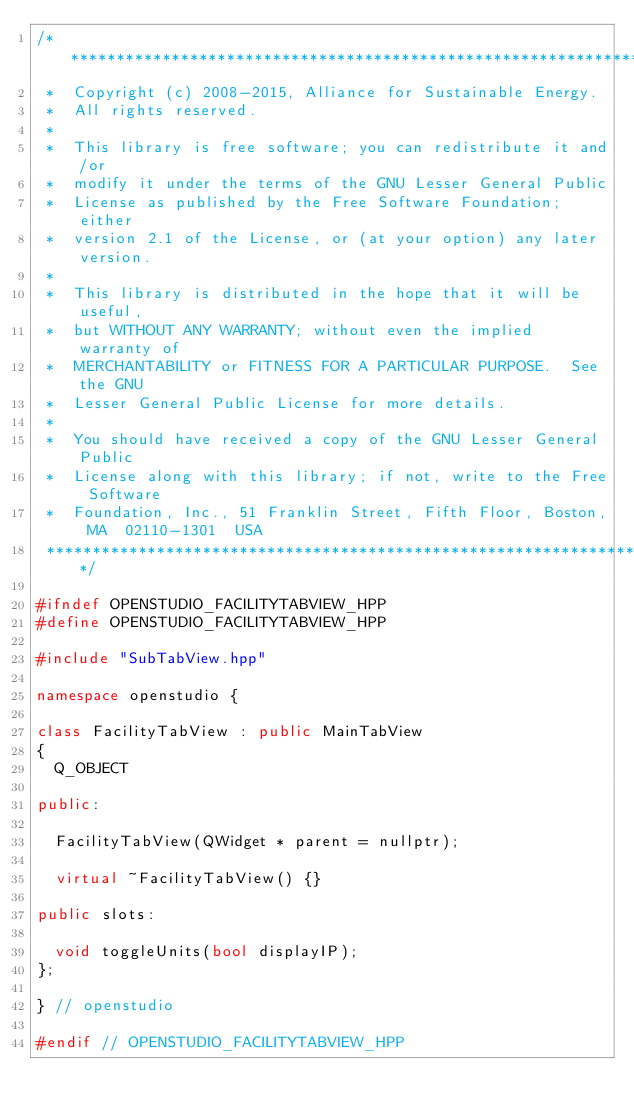Convert code to text. <code><loc_0><loc_0><loc_500><loc_500><_C++_>/**********************************************************************
 *  Copyright (c) 2008-2015, Alliance for Sustainable Energy.  
 *  All rights reserved.
 *  
 *  This library is free software; you can redistribute it and/or
 *  modify it under the terms of the GNU Lesser General Public
 *  License as published by the Free Software Foundation; either
 *  version 2.1 of the License, or (at your option) any later version.
 *  
 *  This library is distributed in the hope that it will be useful,
 *  but WITHOUT ANY WARRANTY; without even the implied warranty of
 *  MERCHANTABILITY or FITNESS FOR A PARTICULAR PURPOSE.  See the GNU
 *  Lesser General Public License for more details.
 *  
 *  You should have received a copy of the GNU Lesser General Public
 *  License along with this library; if not, write to the Free Software
 *  Foundation, Inc., 51 Franklin Street, Fifth Floor, Boston, MA  02110-1301  USA
 **********************************************************************/

#ifndef OPENSTUDIO_FACILITYTABVIEW_HPP
#define OPENSTUDIO_FACILITYTABVIEW_HPP

#include "SubTabView.hpp"

namespace openstudio {

class FacilityTabView : public MainTabView
{
  Q_OBJECT

public:

  FacilityTabView(QWidget * parent = nullptr);

  virtual ~FacilityTabView() {}
 
public slots:

  void toggleUnits(bool displayIP);
};

} // openstudio

#endif // OPENSTUDIO_FACILITYTABVIEW_HPP
</code> 